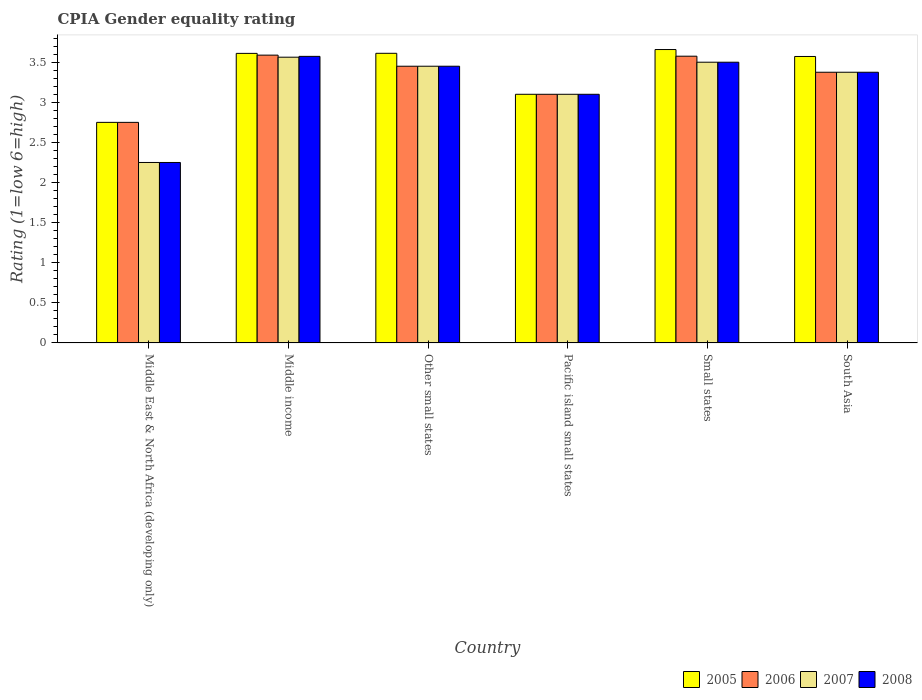Are the number of bars per tick equal to the number of legend labels?
Your answer should be compact. Yes. How many bars are there on the 5th tick from the left?
Offer a terse response. 4. What is the label of the 2nd group of bars from the left?
Your answer should be compact. Middle income. In how many cases, is the number of bars for a given country not equal to the number of legend labels?
Give a very brief answer. 0. What is the CPIA rating in 2005 in South Asia?
Give a very brief answer. 3.57. Across all countries, what is the maximum CPIA rating in 2007?
Your answer should be very brief. 3.56. Across all countries, what is the minimum CPIA rating in 2007?
Your answer should be very brief. 2.25. In which country was the CPIA rating in 2007 maximum?
Provide a short and direct response. Middle income. In which country was the CPIA rating in 2008 minimum?
Ensure brevity in your answer.  Middle East & North Africa (developing only). What is the total CPIA rating in 2005 in the graph?
Your response must be concise. 20.3. What is the difference between the CPIA rating in 2007 in Middle income and that in South Asia?
Make the answer very short. 0.19. What is the difference between the CPIA rating in 2007 in Pacific island small states and the CPIA rating in 2008 in Middle income?
Offer a very short reply. -0.47. What is the average CPIA rating in 2008 per country?
Your answer should be compact. 3.21. What is the difference between the CPIA rating of/in 2005 and CPIA rating of/in 2007 in Middle income?
Your answer should be very brief. 0.05. What is the ratio of the CPIA rating in 2006 in Middle income to that in Small states?
Offer a very short reply. 1. Is the CPIA rating in 2006 in Middle income less than that in Pacific island small states?
Your response must be concise. No. Is the difference between the CPIA rating in 2005 in Middle income and South Asia greater than the difference between the CPIA rating in 2007 in Middle income and South Asia?
Make the answer very short. No. What is the difference between the highest and the second highest CPIA rating in 2006?
Make the answer very short. -0.01. What is the difference between the highest and the lowest CPIA rating in 2005?
Provide a short and direct response. 0.91. In how many countries, is the CPIA rating in 2006 greater than the average CPIA rating in 2006 taken over all countries?
Give a very brief answer. 4. Is the sum of the CPIA rating in 2007 in Middle income and South Asia greater than the maximum CPIA rating in 2006 across all countries?
Provide a succinct answer. Yes. Is it the case that in every country, the sum of the CPIA rating in 2005 and CPIA rating in 2008 is greater than the sum of CPIA rating in 2006 and CPIA rating in 2007?
Keep it short and to the point. No. What does the 1st bar from the left in South Asia represents?
Your answer should be compact. 2005. What does the 4th bar from the right in Middle income represents?
Make the answer very short. 2005. How many countries are there in the graph?
Offer a terse response. 6. Are the values on the major ticks of Y-axis written in scientific E-notation?
Ensure brevity in your answer.  No. Does the graph contain any zero values?
Provide a short and direct response. No. Does the graph contain grids?
Provide a short and direct response. No. Where does the legend appear in the graph?
Ensure brevity in your answer.  Bottom right. What is the title of the graph?
Ensure brevity in your answer.  CPIA Gender equality rating. What is the label or title of the X-axis?
Give a very brief answer. Country. What is the label or title of the Y-axis?
Make the answer very short. Rating (1=low 6=high). What is the Rating (1=low 6=high) of 2005 in Middle East & North Africa (developing only)?
Ensure brevity in your answer.  2.75. What is the Rating (1=low 6=high) in 2006 in Middle East & North Africa (developing only)?
Your answer should be compact. 2.75. What is the Rating (1=low 6=high) in 2007 in Middle East & North Africa (developing only)?
Your answer should be compact. 2.25. What is the Rating (1=low 6=high) in 2008 in Middle East & North Africa (developing only)?
Provide a succinct answer. 2.25. What is the Rating (1=low 6=high) in 2005 in Middle income?
Your response must be concise. 3.61. What is the Rating (1=low 6=high) in 2006 in Middle income?
Offer a terse response. 3.59. What is the Rating (1=low 6=high) of 2007 in Middle income?
Make the answer very short. 3.56. What is the Rating (1=low 6=high) of 2008 in Middle income?
Give a very brief answer. 3.57. What is the Rating (1=low 6=high) of 2005 in Other small states?
Keep it short and to the point. 3.61. What is the Rating (1=low 6=high) of 2006 in Other small states?
Provide a short and direct response. 3.45. What is the Rating (1=low 6=high) of 2007 in Other small states?
Your answer should be compact. 3.45. What is the Rating (1=low 6=high) in 2008 in Other small states?
Provide a short and direct response. 3.45. What is the Rating (1=low 6=high) of 2007 in Pacific island small states?
Provide a short and direct response. 3.1. What is the Rating (1=low 6=high) in 2008 in Pacific island small states?
Offer a very short reply. 3.1. What is the Rating (1=low 6=high) in 2005 in Small states?
Provide a succinct answer. 3.66. What is the Rating (1=low 6=high) in 2006 in Small states?
Your answer should be very brief. 3.58. What is the Rating (1=low 6=high) of 2007 in Small states?
Give a very brief answer. 3.5. What is the Rating (1=low 6=high) in 2005 in South Asia?
Offer a terse response. 3.57. What is the Rating (1=low 6=high) in 2006 in South Asia?
Offer a terse response. 3.38. What is the Rating (1=low 6=high) of 2007 in South Asia?
Keep it short and to the point. 3.38. What is the Rating (1=low 6=high) in 2008 in South Asia?
Provide a succinct answer. 3.38. Across all countries, what is the maximum Rating (1=low 6=high) in 2005?
Provide a short and direct response. 3.66. Across all countries, what is the maximum Rating (1=low 6=high) in 2006?
Your answer should be very brief. 3.59. Across all countries, what is the maximum Rating (1=low 6=high) in 2007?
Provide a succinct answer. 3.56. Across all countries, what is the maximum Rating (1=low 6=high) in 2008?
Your answer should be very brief. 3.57. Across all countries, what is the minimum Rating (1=low 6=high) of 2005?
Your answer should be compact. 2.75. Across all countries, what is the minimum Rating (1=low 6=high) of 2006?
Provide a short and direct response. 2.75. Across all countries, what is the minimum Rating (1=low 6=high) in 2007?
Your answer should be compact. 2.25. Across all countries, what is the minimum Rating (1=low 6=high) of 2008?
Give a very brief answer. 2.25. What is the total Rating (1=low 6=high) in 2005 in the graph?
Ensure brevity in your answer.  20.3. What is the total Rating (1=low 6=high) of 2006 in the graph?
Offer a very short reply. 19.84. What is the total Rating (1=low 6=high) in 2007 in the graph?
Keep it short and to the point. 19.24. What is the total Rating (1=low 6=high) of 2008 in the graph?
Offer a very short reply. 19.25. What is the difference between the Rating (1=low 6=high) in 2005 in Middle East & North Africa (developing only) and that in Middle income?
Make the answer very short. -0.86. What is the difference between the Rating (1=low 6=high) in 2006 in Middle East & North Africa (developing only) and that in Middle income?
Offer a terse response. -0.84. What is the difference between the Rating (1=low 6=high) in 2007 in Middle East & North Africa (developing only) and that in Middle income?
Provide a succinct answer. -1.31. What is the difference between the Rating (1=low 6=high) in 2008 in Middle East & North Africa (developing only) and that in Middle income?
Your response must be concise. -1.32. What is the difference between the Rating (1=low 6=high) in 2005 in Middle East & North Africa (developing only) and that in Other small states?
Offer a very short reply. -0.86. What is the difference between the Rating (1=low 6=high) in 2006 in Middle East & North Africa (developing only) and that in Other small states?
Your answer should be compact. -0.7. What is the difference between the Rating (1=low 6=high) in 2007 in Middle East & North Africa (developing only) and that in Other small states?
Offer a terse response. -1.2. What is the difference between the Rating (1=low 6=high) in 2008 in Middle East & North Africa (developing only) and that in Other small states?
Your response must be concise. -1.2. What is the difference between the Rating (1=low 6=high) in 2005 in Middle East & North Africa (developing only) and that in Pacific island small states?
Offer a very short reply. -0.35. What is the difference between the Rating (1=low 6=high) of 2006 in Middle East & North Africa (developing only) and that in Pacific island small states?
Ensure brevity in your answer.  -0.35. What is the difference between the Rating (1=low 6=high) of 2007 in Middle East & North Africa (developing only) and that in Pacific island small states?
Keep it short and to the point. -0.85. What is the difference between the Rating (1=low 6=high) of 2008 in Middle East & North Africa (developing only) and that in Pacific island small states?
Give a very brief answer. -0.85. What is the difference between the Rating (1=low 6=high) of 2005 in Middle East & North Africa (developing only) and that in Small states?
Keep it short and to the point. -0.91. What is the difference between the Rating (1=low 6=high) of 2006 in Middle East & North Africa (developing only) and that in Small states?
Ensure brevity in your answer.  -0.82. What is the difference between the Rating (1=low 6=high) of 2007 in Middle East & North Africa (developing only) and that in Small states?
Offer a very short reply. -1.25. What is the difference between the Rating (1=low 6=high) of 2008 in Middle East & North Africa (developing only) and that in Small states?
Your answer should be compact. -1.25. What is the difference between the Rating (1=low 6=high) of 2005 in Middle East & North Africa (developing only) and that in South Asia?
Provide a short and direct response. -0.82. What is the difference between the Rating (1=low 6=high) in 2006 in Middle East & North Africa (developing only) and that in South Asia?
Your response must be concise. -0.62. What is the difference between the Rating (1=low 6=high) in 2007 in Middle East & North Africa (developing only) and that in South Asia?
Give a very brief answer. -1.12. What is the difference between the Rating (1=low 6=high) in 2008 in Middle East & North Africa (developing only) and that in South Asia?
Give a very brief answer. -1.12. What is the difference between the Rating (1=low 6=high) of 2005 in Middle income and that in Other small states?
Make the answer very short. -0. What is the difference between the Rating (1=low 6=high) in 2006 in Middle income and that in Other small states?
Your answer should be compact. 0.14. What is the difference between the Rating (1=low 6=high) of 2007 in Middle income and that in Other small states?
Your answer should be compact. 0.11. What is the difference between the Rating (1=low 6=high) of 2008 in Middle income and that in Other small states?
Your response must be concise. 0.12. What is the difference between the Rating (1=low 6=high) of 2005 in Middle income and that in Pacific island small states?
Your answer should be very brief. 0.51. What is the difference between the Rating (1=low 6=high) of 2006 in Middle income and that in Pacific island small states?
Your response must be concise. 0.49. What is the difference between the Rating (1=low 6=high) in 2007 in Middle income and that in Pacific island small states?
Offer a very short reply. 0.46. What is the difference between the Rating (1=low 6=high) of 2008 in Middle income and that in Pacific island small states?
Keep it short and to the point. 0.47. What is the difference between the Rating (1=low 6=high) of 2005 in Middle income and that in Small states?
Your answer should be very brief. -0.05. What is the difference between the Rating (1=low 6=high) of 2006 in Middle income and that in Small states?
Provide a succinct answer. 0.01. What is the difference between the Rating (1=low 6=high) of 2007 in Middle income and that in Small states?
Your answer should be compact. 0.06. What is the difference between the Rating (1=low 6=high) in 2008 in Middle income and that in Small states?
Offer a terse response. 0.07. What is the difference between the Rating (1=low 6=high) in 2005 in Middle income and that in South Asia?
Make the answer very short. 0.04. What is the difference between the Rating (1=low 6=high) in 2006 in Middle income and that in South Asia?
Provide a succinct answer. 0.21. What is the difference between the Rating (1=low 6=high) in 2007 in Middle income and that in South Asia?
Your answer should be compact. 0.19. What is the difference between the Rating (1=low 6=high) of 2008 in Middle income and that in South Asia?
Keep it short and to the point. 0.2. What is the difference between the Rating (1=low 6=high) of 2005 in Other small states and that in Pacific island small states?
Your answer should be compact. 0.51. What is the difference between the Rating (1=low 6=high) of 2007 in Other small states and that in Pacific island small states?
Ensure brevity in your answer.  0.35. What is the difference between the Rating (1=low 6=high) of 2005 in Other small states and that in Small states?
Your answer should be very brief. -0.05. What is the difference between the Rating (1=low 6=high) in 2006 in Other small states and that in Small states?
Give a very brief answer. -0.12. What is the difference between the Rating (1=low 6=high) of 2005 in Other small states and that in South Asia?
Ensure brevity in your answer.  0.04. What is the difference between the Rating (1=low 6=high) of 2006 in Other small states and that in South Asia?
Provide a short and direct response. 0.07. What is the difference between the Rating (1=low 6=high) of 2007 in Other small states and that in South Asia?
Offer a terse response. 0.07. What is the difference between the Rating (1=low 6=high) in 2008 in Other small states and that in South Asia?
Your answer should be very brief. 0.07. What is the difference between the Rating (1=low 6=high) of 2005 in Pacific island small states and that in Small states?
Keep it short and to the point. -0.56. What is the difference between the Rating (1=low 6=high) of 2006 in Pacific island small states and that in Small states?
Make the answer very short. -0.47. What is the difference between the Rating (1=low 6=high) in 2008 in Pacific island small states and that in Small states?
Your response must be concise. -0.4. What is the difference between the Rating (1=low 6=high) of 2005 in Pacific island small states and that in South Asia?
Provide a short and direct response. -0.47. What is the difference between the Rating (1=low 6=high) of 2006 in Pacific island small states and that in South Asia?
Make the answer very short. -0.28. What is the difference between the Rating (1=low 6=high) of 2007 in Pacific island small states and that in South Asia?
Ensure brevity in your answer.  -0.28. What is the difference between the Rating (1=low 6=high) of 2008 in Pacific island small states and that in South Asia?
Ensure brevity in your answer.  -0.28. What is the difference between the Rating (1=low 6=high) in 2005 in Small states and that in South Asia?
Make the answer very short. 0.09. What is the difference between the Rating (1=low 6=high) in 2005 in Middle East & North Africa (developing only) and the Rating (1=low 6=high) in 2006 in Middle income?
Make the answer very short. -0.84. What is the difference between the Rating (1=low 6=high) in 2005 in Middle East & North Africa (developing only) and the Rating (1=low 6=high) in 2007 in Middle income?
Your answer should be compact. -0.81. What is the difference between the Rating (1=low 6=high) in 2005 in Middle East & North Africa (developing only) and the Rating (1=low 6=high) in 2008 in Middle income?
Provide a short and direct response. -0.82. What is the difference between the Rating (1=low 6=high) of 2006 in Middle East & North Africa (developing only) and the Rating (1=low 6=high) of 2007 in Middle income?
Provide a short and direct response. -0.81. What is the difference between the Rating (1=low 6=high) in 2006 in Middle East & North Africa (developing only) and the Rating (1=low 6=high) in 2008 in Middle income?
Your answer should be very brief. -0.82. What is the difference between the Rating (1=low 6=high) of 2007 in Middle East & North Africa (developing only) and the Rating (1=low 6=high) of 2008 in Middle income?
Your response must be concise. -1.32. What is the difference between the Rating (1=low 6=high) in 2005 in Middle East & North Africa (developing only) and the Rating (1=low 6=high) in 2007 in Other small states?
Keep it short and to the point. -0.7. What is the difference between the Rating (1=low 6=high) of 2007 in Middle East & North Africa (developing only) and the Rating (1=low 6=high) of 2008 in Other small states?
Give a very brief answer. -1.2. What is the difference between the Rating (1=low 6=high) in 2005 in Middle East & North Africa (developing only) and the Rating (1=low 6=high) in 2006 in Pacific island small states?
Your answer should be compact. -0.35. What is the difference between the Rating (1=low 6=high) in 2005 in Middle East & North Africa (developing only) and the Rating (1=low 6=high) in 2007 in Pacific island small states?
Your answer should be compact. -0.35. What is the difference between the Rating (1=low 6=high) in 2005 in Middle East & North Africa (developing only) and the Rating (1=low 6=high) in 2008 in Pacific island small states?
Ensure brevity in your answer.  -0.35. What is the difference between the Rating (1=low 6=high) of 2006 in Middle East & North Africa (developing only) and the Rating (1=low 6=high) of 2007 in Pacific island small states?
Offer a very short reply. -0.35. What is the difference between the Rating (1=low 6=high) of 2006 in Middle East & North Africa (developing only) and the Rating (1=low 6=high) of 2008 in Pacific island small states?
Give a very brief answer. -0.35. What is the difference between the Rating (1=low 6=high) in 2007 in Middle East & North Africa (developing only) and the Rating (1=low 6=high) in 2008 in Pacific island small states?
Your response must be concise. -0.85. What is the difference between the Rating (1=low 6=high) in 2005 in Middle East & North Africa (developing only) and the Rating (1=low 6=high) in 2006 in Small states?
Keep it short and to the point. -0.82. What is the difference between the Rating (1=low 6=high) in 2005 in Middle East & North Africa (developing only) and the Rating (1=low 6=high) in 2007 in Small states?
Offer a terse response. -0.75. What is the difference between the Rating (1=low 6=high) of 2005 in Middle East & North Africa (developing only) and the Rating (1=low 6=high) of 2008 in Small states?
Your answer should be compact. -0.75. What is the difference between the Rating (1=low 6=high) in 2006 in Middle East & North Africa (developing only) and the Rating (1=low 6=high) in 2007 in Small states?
Ensure brevity in your answer.  -0.75. What is the difference between the Rating (1=low 6=high) of 2006 in Middle East & North Africa (developing only) and the Rating (1=low 6=high) of 2008 in Small states?
Provide a short and direct response. -0.75. What is the difference between the Rating (1=low 6=high) of 2007 in Middle East & North Africa (developing only) and the Rating (1=low 6=high) of 2008 in Small states?
Offer a terse response. -1.25. What is the difference between the Rating (1=low 6=high) in 2005 in Middle East & North Africa (developing only) and the Rating (1=low 6=high) in 2006 in South Asia?
Your answer should be compact. -0.62. What is the difference between the Rating (1=low 6=high) of 2005 in Middle East & North Africa (developing only) and the Rating (1=low 6=high) of 2007 in South Asia?
Keep it short and to the point. -0.62. What is the difference between the Rating (1=low 6=high) of 2005 in Middle East & North Africa (developing only) and the Rating (1=low 6=high) of 2008 in South Asia?
Offer a very short reply. -0.62. What is the difference between the Rating (1=low 6=high) of 2006 in Middle East & North Africa (developing only) and the Rating (1=low 6=high) of 2007 in South Asia?
Keep it short and to the point. -0.62. What is the difference between the Rating (1=low 6=high) in 2006 in Middle East & North Africa (developing only) and the Rating (1=low 6=high) in 2008 in South Asia?
Ensure brevity in your answer.  -0.62. What is the difference between the Rating (1=low 6=high) in 2007 in Middle East & North Africa (developing only) and the Rating (1=low 6=high) in 2008 in South Asia?
Provide a succinct answer. -1.12. What is the difference between the Rating (1=low 6=high) of 2005 in Middle income and the Rating (1=low 6=high) of 2006 in Other small states?
Give a very brief answer. 0.16. What is the difference between the Rating (1=low 6=high) in 2005 in Middle income and the Rating (1=low 6=high) in 2007 in Other small states?
Keep it short and to the point. 0.16. What is the difference between the Rating (1=low 6=high) in 2005 in Middle income and the Rating (1=low 6=high) in 2008 in Other small states?
Offer a very short reply. 0.16. What is the difference between the Rating (1=low 6=high) of 2006 in Middle income and the Rating (1=low 6=high) of 2007 in Other small states?
Provide a succinct answer. 0.14. What is the difference between the Rating (1=low 6=high) in 2006 in Middle income and the Rating (1=low 6=high) in 2008 in Other small states?
Your answer should be compact. 0.14. What is the difference between the Rating (1=low 6=high) of 2007 in Middle income and the Rating (1=low 6=high) of 2008 in Other small states?
Your answer should be compact. 0.11. What is the difference between the Rating (1=low 6=high) in 2005 in Middle income and the Rating (1=low 6=high) in 2006 in Pacific island small states?
Offer a very short reply. 0.51. What is the difference between the Rating (1=low 6=high) in 2005 in Middle income and the Rating (1=low 6=high) in 2007 in Pacific island small states?
Your answer should be very brief. 0.51. What is the difference between the Rating (1=low 6=high) of 2005 in Middle income and the Rating (1=low 6=high) of 2008 in Pacific island small states?
Your response must be concise. 0.51. What is the difference between the Rating (1=low 6=high) in 2006 in Middle income and the Rating (1=low 6=high) in 2007 in Pacific island small states?
Give a very brief answer. 0.49. What is the difference between the Rating (1=low 6=high) in 2006 in Middle income and the Rating (1=low 6=high) in 2008 in Pacific island small states?
Give a very brief answer. 0.49. What is the difference between the Rating (1=low 6=high) of 2007 in Middle income and the Rating (1=low 6=high) of 2008 in Pacific island small states?
Your answer should be compact. 0.46. What is the difference between the Rating (1=low 6=high) in 2005 in Middle income and the Rating (1=low 6=high) in 2006 in Small states?
Keep it short and to the point. 0.04. What is the difference between the Rating (1=low 6=high) in 2005 in Middle income and the Rating (1=low 6=high) in 2007 in Small states?
Your answer should be compact. 0.11. What is the difference between the Rating (1=low 6=high) in 2005 in Middle income and the Rating (1=low 6=high) in 2008 in Small states?
Give a very brief answer. 0.11. What is the difference between the Rating (1=low 6=high) of 2006 in Middle income and the Rating (1=low 6=high) of 2007 in Small states?
Your response must be concise. 0.09. What is the difference between the Rating (1=low 6=high) in 2006 in Middle income and the Rating (1=low 6=high) in 2008 in Small states?
Ensure brevity in your answer.  0.09. What is the difference between the Rating (1=low 6=high) of 2007 in Middle income and the Rating (1=low 6=high) of 2008 in Small states?
Keep it short and to the point. 0.06. What is the difference between the Rating (1=low 6=high) in 2005 in Middle income and the Rating (1=low 6=high) in 2006 in South Asia?
Make the answer very short. 0.23. What is the difference between the Rating (1=low 6=high) of 2005 in Middle income and the Rating (1=low 6=high) of 2007 in South Asia?
Provide a short and direct response. 0.23. What is the difference between the Rating (1=low 6=high) of 2005 in Middle income and the Rating (1=low 6=high) of 2008 in South Asia?
Ensure brevity in your answer.  0.23. What is the difference between the Rating (1=low 6=high) of 2006 in Middle income and the Rating (1=low 6=high) of 2007 in South Asia?
Your answer should be very brief. 0.21. What is the difference between the Rating (1=low 6=high) of 2006 in Middle income and the Rating (1=low 6=high) of 2008 in South Asia?
Offer a very short reply. 0.21. What is the difference between the Rating (1=low 6=high) in 2007 in Middle income and the Rating (1=low 6=high) in 2008 in South Asia?
Offer a very short reply. 0.19. What is the difference between the Rating (1=low 6=high) of 2005 in Other small states and the Rating (1=low 6=high) of 2006 in Pacific island small states?
Your response must be concise. 0.51. What is the difference between the Rating (1=low 6=high) in 2005 in Other small states and the Rating (1=low 6=high) in 2007 in Pacific island small states?
Your response must be concise. 0.51. What is the difference between the Rating (1=low 6=high) in 2005 in Other small states and the Rating (1=low 6=high) in 2008 in Pacific island small states?
Offer a very short reply. 0.51. What is the difference between the Rating (1=low 6=high) in 2006 in Other small states and the Rating (1=low 6=high) in 2008 in Pacific island small states?
Your response must be concise. 0.35. What is the difference between the Rating (1=low 6=high) in 2007 in Other small states and the Rating (1=low 6=high) in 2008 in Pacific island small states?
Ensure brevity in your answer.  0.35. What is the difference between the Rating (1=low 6=high) of 2005 in Other small states and the Rating (1=low 6=high) of 2006 in Small states?
Provide a succinct answer. 0.04. What is the difference between the Rating (1=low 6=high) of 2005 in Other small states and the Rating (1=low 6=high) of 2007 in Small states?
Keep it short and to the point. 0.11. What is the difference between the Rating (1=low 6=high) of 2006 in Other small states and the Rating (1=low 6=high) of 2007 in Small states?
Make the answer very short. -0.05. What is the difference between the Rating (1=low 6=high) in 2006 in Other small states and the Rating (1=low 6=high) in 2008 in Small states?
Provide a succinct answer. -0.05. What is the difference between the Rating (1=low 6=high) in 2005 in Other small states and the Rating (1=low 6=high) in 2006 in South Asia?
Keep it short and to the point. 0.24. What is the difference between the Rating (1=low 6=high) in 2005 in Other small states and the Rating (1=low 6=high) in 2007 in South Asia?
Give a very brief answer. 0.24. What is the difference between the Rating (1=low 6=high) of 2005 in Other small states and the Rating (1=low 6=high) of 2008 in South Asia?
Ensure brevity in your answer.  0.24. What is the difference between the Rating (1=low 6=high) of 2006 in Other small states and the Rating (1=low 6=high) of 2007 in South Asia?
Provide a short and direct response. 0.07. What is the difference between the Rating (1=low 6=high) in 2006 in Other small states and the Rating (1=low 6=high) in 2008 in South Asia?
Ensure brevity in your answer.  0.07. What is the difference between the Rating (1=low 6=high) in 2007 in Other small states and the Rating (1=low 6=high) in 2008 in South Asia?
Keep it short and to the point. 0.07. What is the difference between the Rating (1=low 6=high) in 2005 in Pacific island small states and the Rating (1=low 6=high) in 2006 in Small states?
Offer a terse response. -0.47. What is the difference between the Rating (1=low 6=high) in 2005 in Pacific island small states and the Rating (1=low 6=high) in 2007 in Small states?
Your answer should be compact. -0.4. What is the difference between the Rating (1=low 6=high) of 2005 in Pacific island small states and the Rating (1=low 6=high) of 2008 in Small states?
Your answer should be very brief. -0.4. What is the difference between the Rating (1=low 6=high) in 2006 in Pacific island small states and the Rating (1=low 6=high) in 2007 in Small states?
Make the answer very short. -0.4. What is the difference between the Rating (1=low 6=high) of 2005 in Pacific island small states and the Rating (1=low 6=high) of 2006 in South Asia?
Offer a very short reply. -0.28. What is the difference between the Rating (1=low 6=high) of 2005 in Pacific island small states and the Rating (1=low 6=high) of 2007 in South Asia?
Provide a short and direct response. -0.28. What is the difference between the Rating (1=low 6=high) of 2005 in Pacific island small states and the Rating (1=low 6=high) of 2008 in South Asia?
Provide a succinct answer. -0.28. What is the difference between the Rating (1=low 6=high) in 2006 in Pacific island small states and the Rating (1=low 6=high) in 2007 in South Asia?
Your response must be concise. -0.28. What is the difference between the Rating (1=low 6=high) of 2006 in Pacific island small states and the Rating (1=low 6=high) of 2008 in South Asia?
Provide a short and direct response. -0.28. What is the difference between the Rating (1=low 6=high) in 2007 in Pacific island small states and the Rating (1=low 6=high) in 2008 in South Asia?
Offer a terse response. -0.28. What is the difference between the Rating (1=low 6=high) in 2005 in Small states and the Rating (1=low 6=high) in 2006 in South Asia?
Give a very brief answer. 0.28. What is the difference between the Rating (1=low 6=high) in 2005 in Small states and the Rating (1=low 6=high) in 2007 in South Asia?
Your answer should be compact. 0.28. What is the difference between the Rating (1=low 6=high) of 2005 in Small states and the Rating (1=low 6=high) of 2008 in South Asia?
Your answer should be very brief. 0.28. What is the difference between the Rating (1=low 6=high) in 2007 in Small states and the Rating (1=low 6=high) in 2008 in South Asia?
Offer a very short reply. 0.12. What is the average Rating (1=low 6=high) in 2005 per country?
Ensure brevity in your answer.  3.38. What is the average Rating (1=low 6=high) of 2006 per country?
Make the answer very short. 3.31. What is the average Rating (1=low 6=high) of 2007 per country?
Your response must be concise. 3.21. What is the average Rating (1=low 6=high) of 2008 per country?
Provide a succinct answer. 3.21. What is the difference between the Rating (1=low 6=high) of 2005 and Rating (1=low 6=high) of 2006 in Middle East & North Africa (developing only)?
Offer a very short reply. 0. What is the difference between the Rating (1=low 6=high) of 2005 and Rating (1=low 6=high) of 2007 in Middle East & North Africa (developing only)?
Ensure brevity in your answer.  0.5. What is the difference between the Rating (1=low 6=high) of 2005 and Rating (1=low 6=high) of 2006 in Middle income?
Your answer should be compact. 0.02. What is the difference between the Rating (1=low 6=high) in 2005 and Rating (1=low 6=high) in 2007 in Middle income?
Offer a very short reply. 0.05. What is the difference between the Rating (1=low 6=high) in 2005 and Rating (1=low 6=high) in 2008 in Middle income?
Make the answer very short. 0.04. What is the difference between the Rating (1=low 6=high) in 2006 and Rating (1=low 6=high) in 2007 in Middle income?
Make the answer very short. 0.03. What is the difference between the Rating (1=low 6=high) in 2006 and Rating (1=low 6=high) in 2008 in Middle income?
Offer a terse response. 0.02. What is the difference between the Rating (1=low 6=high) of 2007 and Rating (1=low 6=high) of 2008 in Middle income?
Ensure brevity in your answer.  -0.01. What is the difference between the Rating (1=low 6=high) of 2005 and Rating (1=low 6=high) of 2006 in Other small states?
Provide a short and direct response. 0.16. What is the difference between the Rating (1=low 6=high) of 2005 and Rating (1=low 6=high) of 2007 in Other small states?
Ensure brevity in your answer.  0.16. What is the difference between the Rating (1=low 6=high) in 2005 and Rating (1=low 6=high) in 2008 in Other small states?
Your answer should be very brief. 0.16. What is the difference between the Rating (1=low 6=high) of 2007 and Rating (1=low 6=high) of 2008 in Other small states?
Provide a short and direct response. 0. What is the difference between the Rating (1=low 6=high) of 2005 and Rating (1=low 6=high) of 2006 in Pacific island small states?
Your response must be concise. 0. What is the difference between the Rating (1=low 6=high) of 2005 and Rating (1=low 6=high) of 2008 in Pacific island small states?
Give a very brief answer. 0. What is the difference between the Rating (1=low 6=high) of 2006 and Rating (1=low 6=high) of 2008 in Pacific island small states?
Ensure brevity in your answer.  0. What is the difference between the Rating (1=low 6=high) in 2007 and Rating (1=low 6=high) in 2008 in Pacific island small states?
Provide a succinct answer. 0. What is the difference between the Rating (1=low 6=high) in 2005 and Rating (1=low 6=high) in 2006 in Small states?
Make the answer very short. 0.08. What is the difference between the Rating (1=low 6=high) of 2005 and Rating (1=low 6=high) of 2007 in Small states?
Your response must be concise. 0.16. What is the difference between the Rating (1=low 6=high) in 2005 and Rating (1=low 6=high) in 2008 in Small states?
Your answer should be very brief. 0.16. What is the difference between the Rating (1=low 6=high) of 2006 and Rating (1=low 6=high) of 2007 in Small states?
Provide a succinct answer. 0.07. What is the difference between the Rating (1=low 6=high) in 2006 and Rating (1=low 6=high) in 2008 in Small states?
Your response must be concise. 0.07. What is the difference between the Rating (1=low 6=high) in 2007 and Rating (1=low 6=high) in 2008 in Small states?
Give a very brief answer. 0. What is the difference between the Rating (1=low 6=high) in 2005 and Rating (1=low 6=high) in 2006 in South Asia?
Your answer should be very brief. 0.2. What is the difference between the Rating (1=low 6=high) in 2005 and Rating (1=low 6=high) in 2007 in South Asia?
Offer a very short reply. 0.2. What is the difference between the Rating (1=low 6=high) in 2005 and Rating (1=low 6=high) in 2008 in South Asia?
Offer a terse response. 0.2. What is the difference between the Rating (1=low 6=high) in 2006 and Rating (1=low 6=high) in 2007 in South Asia?
Provide a succinct answer. 0. What is the difference between the Rating (1=low 6=high) in 2006 and Rating (1=low 6=high) in 2008 in South Asia?
Your answer should be compact. 0. What is the difference between the Rating (1=low 6=high) in 2007 and Rating (1=low 6=high) in 2008 in South Asia?
Provide a succinct answer. 0. What is the ratio of the Rating (1=low 6=high) of 2005 in Middle East & North Africa (developing only) to that in Middle income?
Offer a terse response. 0.76. What is the ratio of the Rating (1=low 6=high) in 2006 in Middle East & North Africa (developing only) to that in Middle income?
Give a very brief answer. 0.77. What is the ratio of the Rating (1=low 6=high) in 2007 in Middle East & North Africa (developing only) to that in Middle income?
Give a very brief answer. 0.63. What is the ratio of the Rating (1=low 6=high) in 2008 in Middle East & North Africa (developing only) to that in Middle income?
Offer a terse response. 0.63. What is the ratio of the Rating (1=low 6=high) in 2005 in Middle East & North Africa (developing only) to that in Other small states?
Ensure brevity in your answer.  0.76. What is the ratio of the Rating (1=low 6=high) of 2006 in Middle East & North Africa (developing only) to that in Other small states?
Keep it short and to the point. 0.8. What is the ratio of the Rating (1=low 6=high) in 2007 in Middle East & North Africa (developing only) to that in Other small states?
Your response must be concise. 0.65. What is the ratio of the Rating (1=low 6=high) of 2008 in Middle East & North Africa (developing only) to that in Other small states?
Your response must be concise. 0.65. What is the ratio of the Rating (1=low 6=high) of 2005 in Middle East & North Africa (developing only) to that in Pacific island small states?
Your answer should be very brief. 0.89. What is the ratio of the Rating (1=low 6=high) in 2006 in Middle East & North Africa (developing only) to that in Pacific island small states?
Ensure brevity in your answer.  0.89. What is the ratio of the Rating (1=low 6=high) in 2007 in Middle East & North Africa (developing only) to that in Pacific island small states?
Provide a short and direct response. 0.73. What is the ratio of the Rating (1=low 6=high) of 2008 in Middle East & North Africa (developing only) to that in Pacific island small states?
Offer a terse response. 0.73. What is the ratio of the Rating (1=low 6=high) in 2005 in Middle East & North Africa (developing only) to that in Small states?
Provide a succinct answer. 0.75. What is the ratio of the Rating (1=low 6=high) in 2006 in Middle East & North Africa (developing only) to that in Small states?
Your response must be concise. 0.77. What is the ratio of the Rating (1=low 6=high) in 2007 in Middle East & North Africa (developing only) to that in Small states?
Provide a succinct answer. 0.64. What is the ratio of the Rating (1=low 6=high) of 2008 in Middle East & North Africa (developing only) to that in Small states?
Offer a terse response. 0.64. What is the ratio of the Rating (1=low 6=high) in 2005 in Middle East & North Africa (developing only) to that in South Asia?
Your response must be concise. 0.77. What is the ratio of the Rating (1=low 6=high) in 2006 in Middle East & North Africa (developing only) to that in South Asia?
Provide a short and direct response. 0.81. What is the ratio of the Rating (1=low 6=high) of 2006 in Middle income to that in Other small states?
Your response must be concise. 1.04. What is the ratio of the Rating (1=low 6=high) in 2007 in Middle income to that in Other small states?
Provide a succinct answer. 1.03. What is the ratio of the Rating (1=low 6=high) in 2008 in Middle income to that in Other small states?
Offer a very short reply. 1.04. What is the ratio of the Rating (1=low 6=high) of 2005 in Middle income to that in Pacific island small states?
Make the answer very short. 1.16. What is the ratio of the Rating (1=low 6=high) of 2006 in Middle income to that in Pacific island small states?
Keep it short and to the point. 1.16. What is the ratio of the Rating (1=low 6=high) in 2007 in Middle income to that in Pacific island small states?
Provide a short and direct response. 1.15. What is the ratio of the Rating (1=low 6=high) in 2008 in Middle income to that in Pacific island small states?
Your answer should be very brief. 1.15. What is the ratio of the Rating (1=low 6=high) in 2005 in Middle income to that in Small states?
Make the answer very short. 0.99. What is the ratio of the Rating (1=low 6=high) of 2007 in Middle income to that in Small states?
Keep it short and to the point. 1.02. What is the ratio of the Rating (1=low 6=high) of 2008 in Middle income to that in Small states?
Your answer should be very brief. 1.02. What is the ratio of the Rating (1=low 6=high) in 2005 in Middle income to that in South Asia?
Your response must be concise. 1.01. What is the ratio of the Rating (1=low 6=high) in 2006 in Middle income to that in South Asia?
Provide a succinct answer. 1.06. What is the ratio of the Rating (1=low 6=high) of 2007 in Middle income to that in South Asia?
Your response must be concise. 1.06. What is the ratio of the Rating (1=low 6=high) of 2008 in Middle income to that in South Asia?
Offer a very short reply. 1.06. What is the ratio of the Rating (1=low 6=high) in 2005 in Other small states to that in Pacific island small states?
Your response must be concise. 1.16. What is the ratio of the Rating (1=low 6=high) in 2006 in Other small states to that in Pacific island small states?
Make the answer very short. 1.11. What is the ratio of the Rating (1=low 6=high) of 2007 in Other small states to that in Pacific island small states?
Ensure brevity in your answer.  1.11. What is the ratio of the Rating (1=low 6=high) of 2008 in Other small states to that in Pacific island small states?
Keep it short and to the point. 1.11. What is the ratio of the Rating (1=low 6=high) in 2005 in Other small states to that in Small states?
Keep it short and to the point. 0.99. What is the ratio of the Rating (1=low 6=high) in 2007 in Other small states to that in Small states?
Provide a short and direct response. 0.99. What is the ratio of the Rating (1=low 6=high) in 2008 in Other small states to that in Small states?
Offer a very short reply. 0.99. What is the ratio of the Rating (1=low 6=high) in 2005 in Other small states to that in South Asia?
Your response must be concise. 1.01. What is the ratio of the Rating (1=low 6=high) in 2006 in Other small states to that in South Asia?
Your answer should be very brief. 1.02. What is the ratio of the Rating (1=low 6=high) of 2007 in Other small states to that in South Asia?
Give a very brief answer. 1.02. What is the ratio of the Rating (1=low 6=high) of 2008 in Other small states to that in South Asia?
Give a very brief answer. 1.02. What is the ratio of the Rating (1=low 6=high) of 2005 in Pacific island small states to that in Small states?
Keep it short and to the point. 0.85. What is the ratio of the Rating (1=low 6=high) in 2006 in Pacific island small states to that in Small states?
Provide a short and direct response. 0.87. What is the ratio of the Rating (1=low 6=high) in 2007 in Pacific island small states to that in Small states?
Provide a succinct answer. 0.89. What is the ratio of the Rating (1=low 6=high) of 2008 in Pacific island small states to that in Small states?
Keep it short and to the point. 0.89. What is the ratio of the Rating (1=low 6=high) of 2005 in Pacific island small states to that in South Asia?
Your response must be concise. 0.87. What is the ratio of the Rating (1=low 6=high) in 2006 in Pacific island small states to that in South Asia?
Give a very brief answer. 0.92. What is the ratio of the Rating (1=low 6=high) of 2007 in Pacific island small states to that in South Asia?
Provide a short and direct response. 0.92. What is the ratio of the Rating (1=low 6=high) of 2008 in Pacific island small states to that in South Asia?
Make the answer very short. 0.92. What is the ratio of the Rating (1=low 6=high) in 2005 in Small states to that in South Asia?
Provide a short and direct response. 1.02. What is the ratio of the Rating (1=low 6=high) in 2006 in Small states to that in South Asia?
Ensure brevity in your answer.  1.06. What is the ratio of the Rating (1=low 6=high) in 2008 in Small states to that in South Asia?
Keep it short and to the point. 1.04. What is the difference between the highest and the second highest Rating (1=low 6=high) in 2005?
Your answer should be compact. 0.05. What is the difference between the highest and the second highest Rating (1=low 6=high) of 2006?
Keep it short and to the point. 0.01. What is the difference between the highest and the second highest Rating (1=low 6=high) in 2007?
Your answer should be compact. 0.06. What is the difference between the highest and the second highest Rating (1=low 6=high) in 2008?
Your response must be concise. 0.07. What is the difference between the highest and the lowest Rating (1=low 6=high) of 2005?
Provide a short and direct response. 0.91. What is the difference between the highest and the lowest Rating (1=low 6=high) of 2006?
Offer a terse response. 0.84. What is the difference between the highest and the lowest Rating (1=low 6=high) in 2007?
Make the answer very short. 1.31. What is the difference between the highest and the lowest Rating (1=low 6=high) of 2008?
Provide a succinct answer. 1.32. 